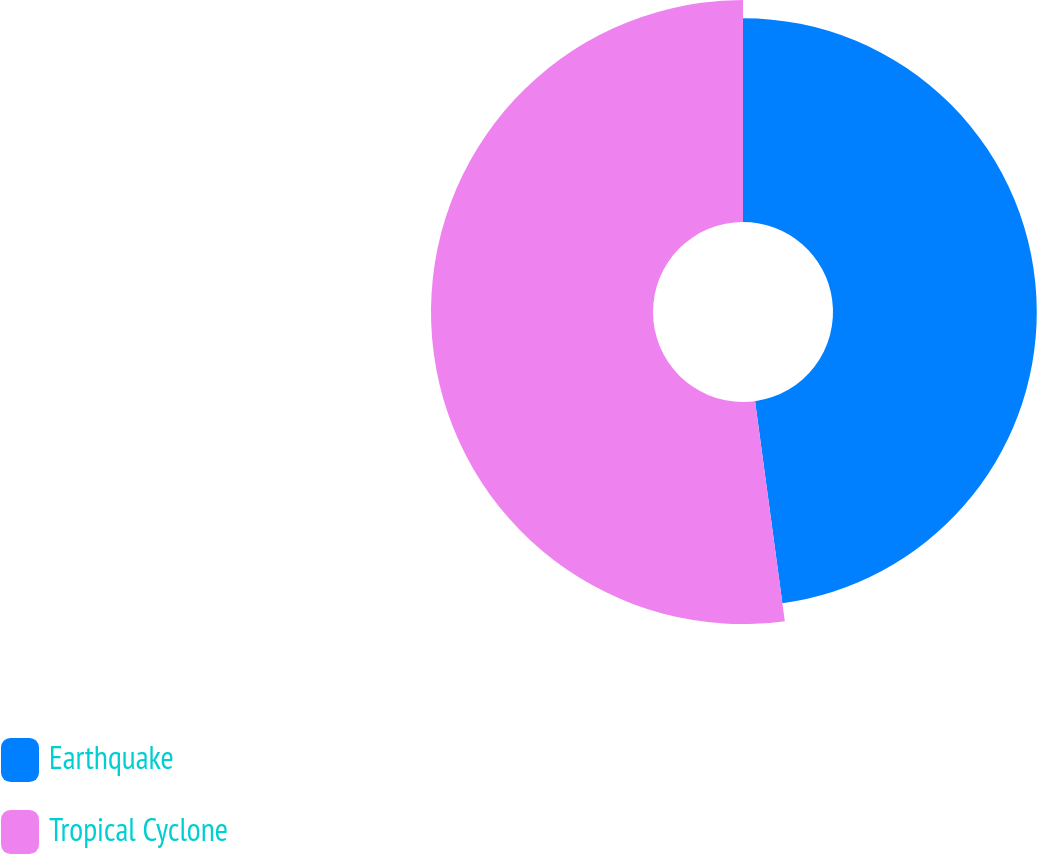<chart> <loc_0><loc_0><loc_500><loc_500><pie_chart><fcel>Earthquake<fcel>Tropical Cyclone<nl><fcel>47.86%<fcel>52.14%<nl></chart> 